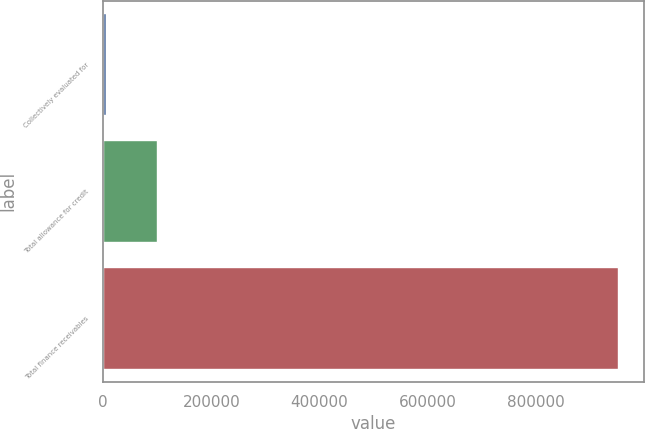Convert chart to OTSL. <chart><loc_0><loc_0><loc_500><loc_500><bar_chart><fcel>Collectively evaluated for<fcel>Total allowance for credit<fcel>Total finance receivables<nl><fcel>5339<fcel>100037<fcel>952321<nl></chart> 